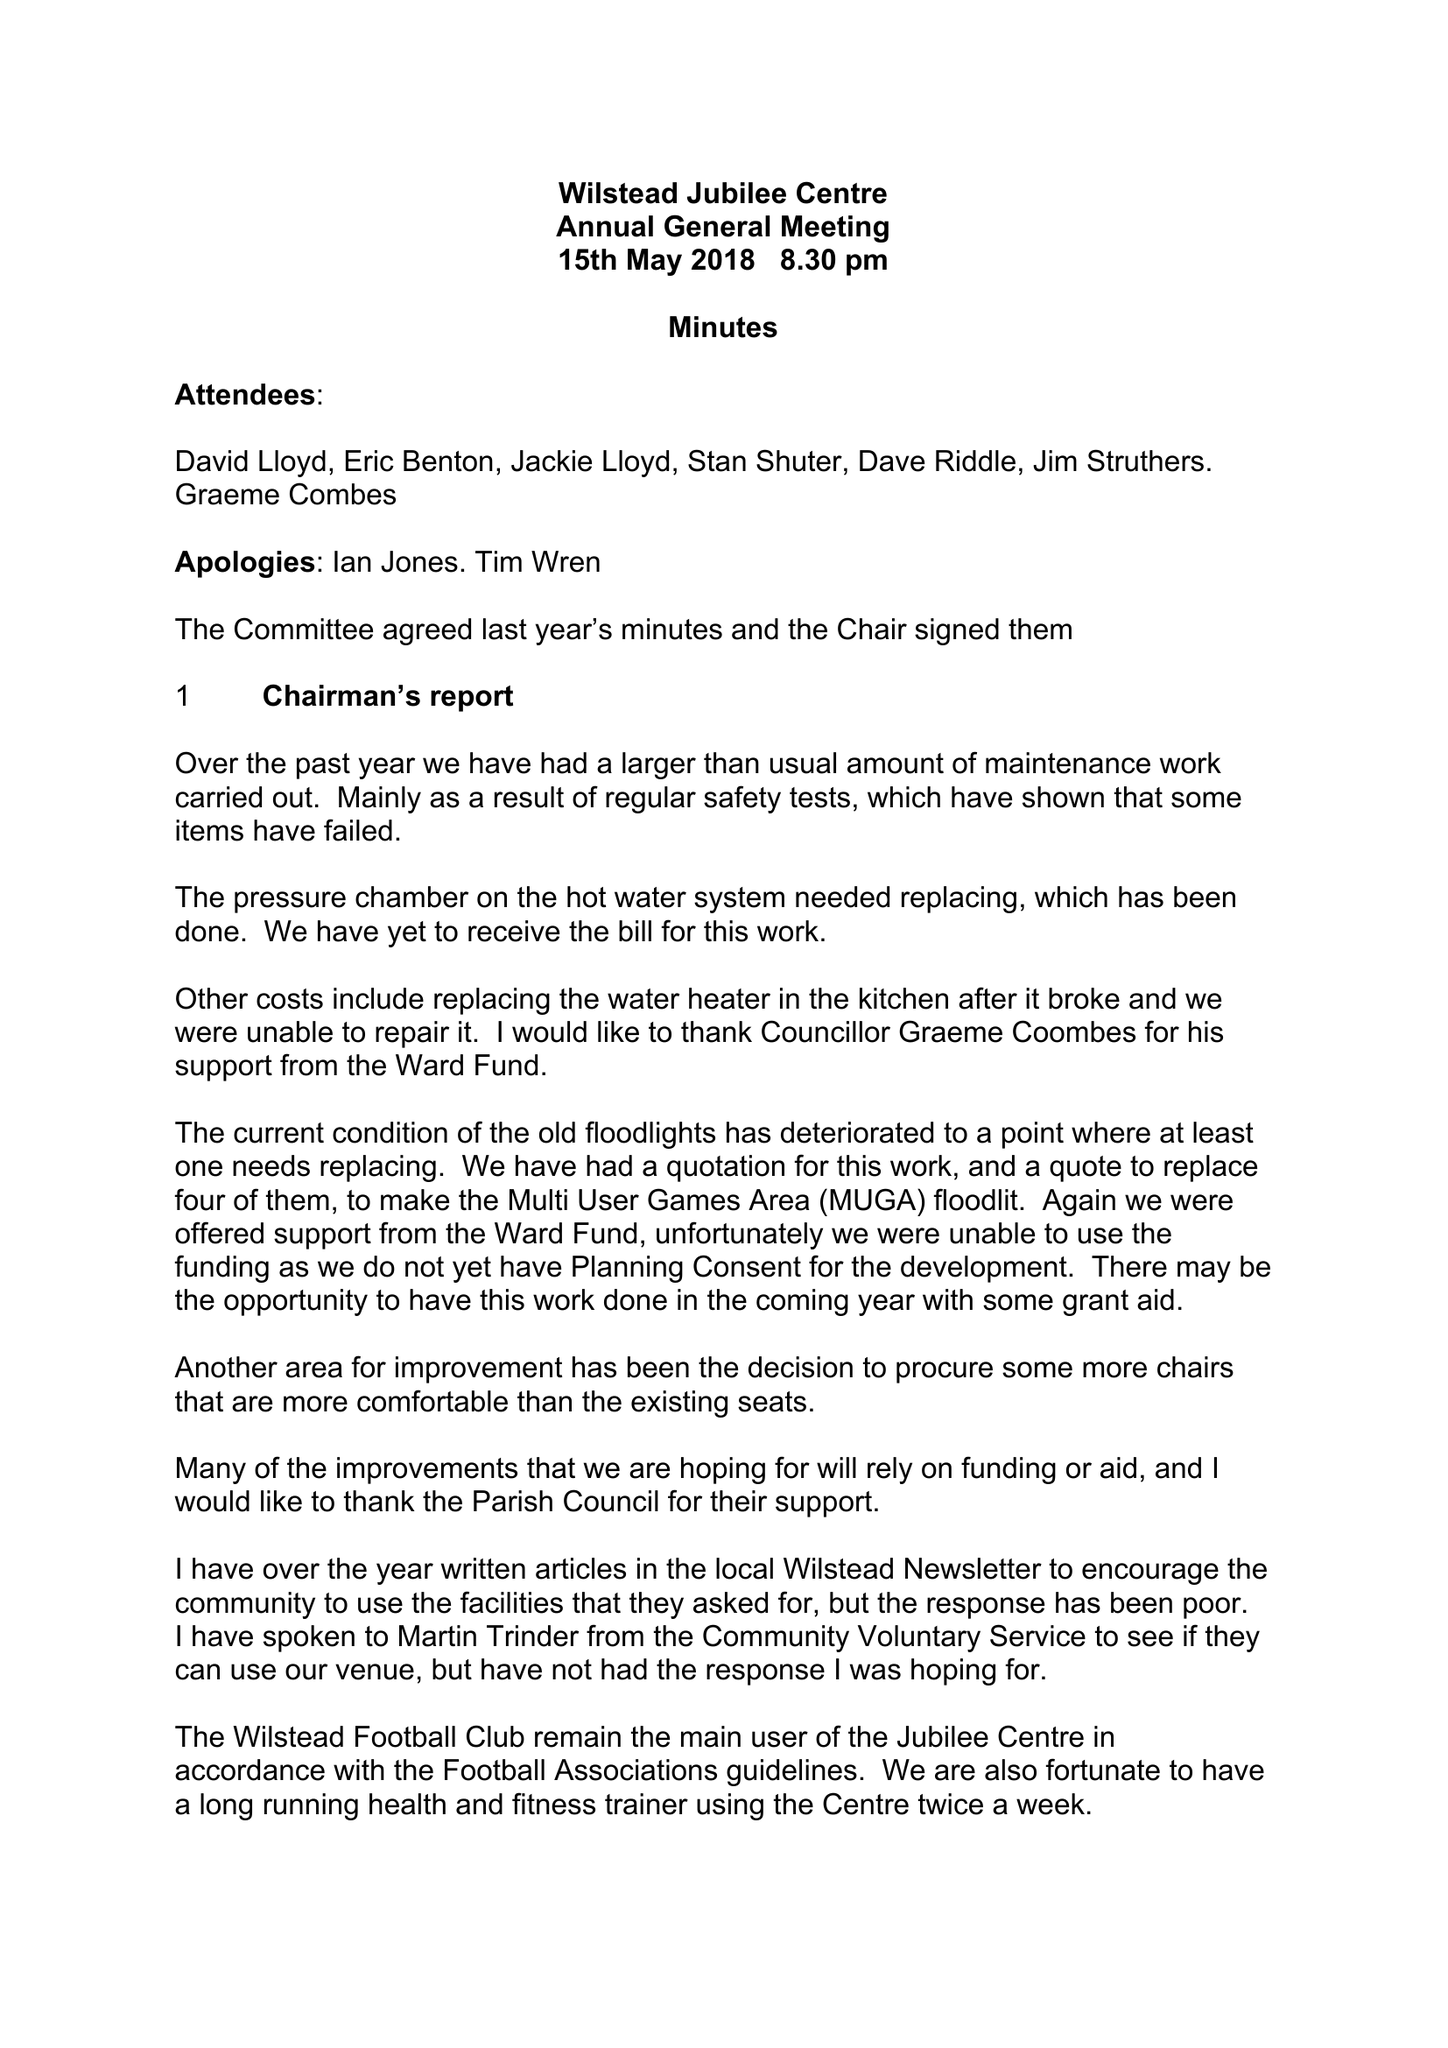What is the value for the address__street_line?
Answer the question using a single word or phrase. 41A LUTON ROAD 